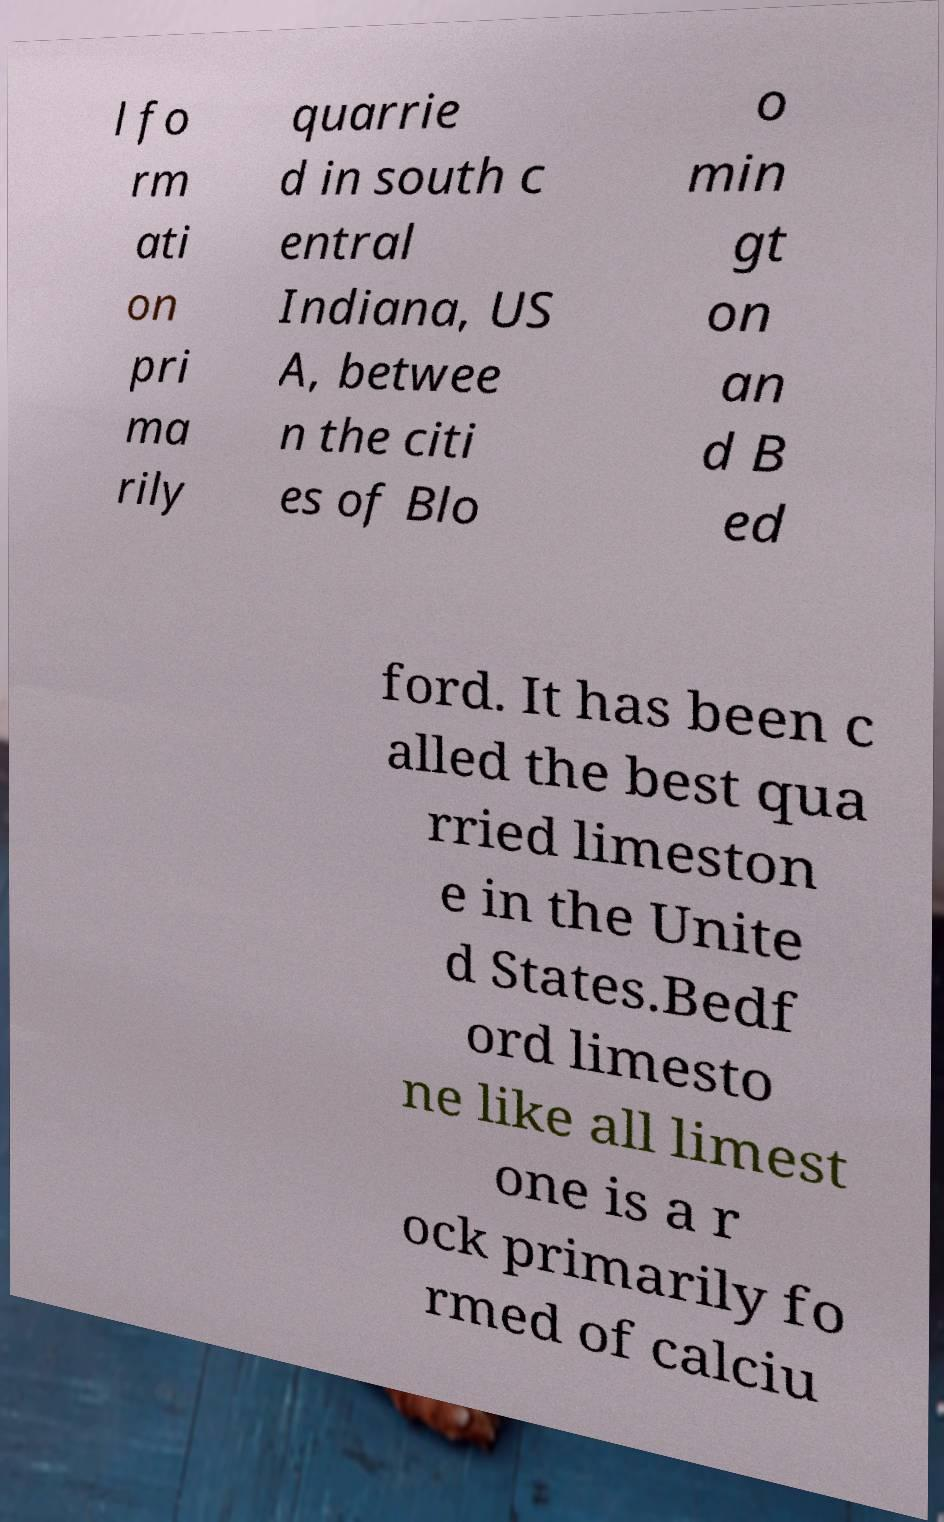For documentation purposes, I need the text within this image transcribed. Could you provide that? l fo rm ati on pri ma rily quarrie d in south c entral Indiana, US A, betwee n the citi es of Blo o min gt on an d B ed ford. It has been c alled the best qua rried limeston e in the Unite d States.Bedf ord limesto ne like all limest one is a r ock primarily fo rmed of calciu 